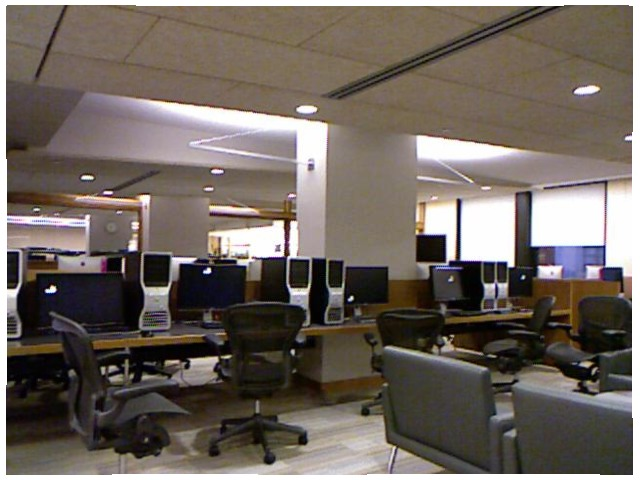<image>
Is the table in front of the chair? Yes. The table is positioned in front of the chair, appearing closer to the camera viewpoint. Is the chair on the table? Yes. Looking at the image, I can see the chair is positioned on top of the table, with the table providing support. Is there a computer to the left of the cpu? Yes. From this viewpoint, the computer is positioned to the left side relative to the cpu. 